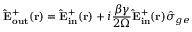<formula> <loc_0><loc_0><loc_500><loc_500>{ \hat { E } _ { o u t } ^ { + } ( { r } ) } = { \hat { E } _ { i n } ^ { + } ( { r } ) } + i \frac { \beta \gamma } { 2 \Omega } { \hat { E } _ { i n } ^ { + } ( { r } ) } \hat { \sigma } _ { g e }</formula> 